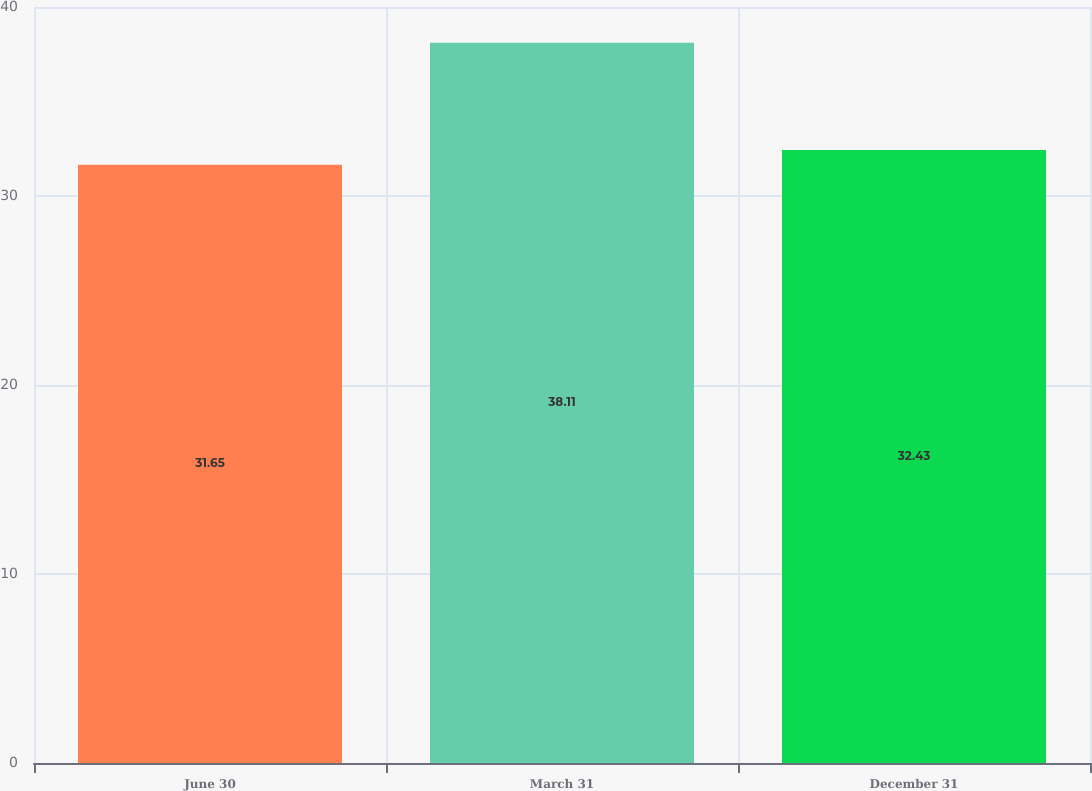Convert chart. <chart><loc_0><loc_0><loc_500><loc_500><bar_chart><fcel>June 30<fcel>March 31<fcel>December 31<nl><fcel>31.65<fcel>38.11<fcel>32.43<nl></chart> 